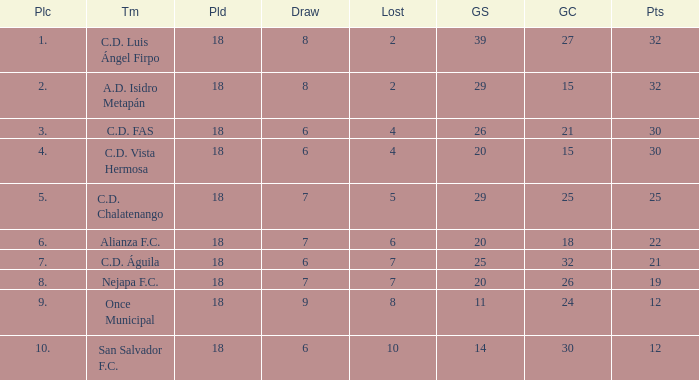What is the lowest played with a lost bigger than 10? None. 